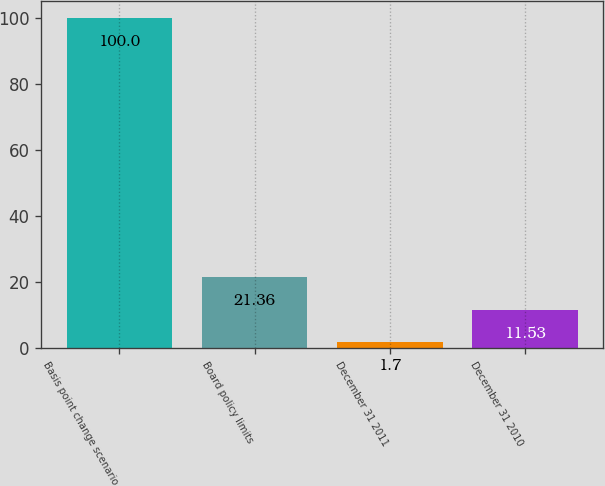Convert chart to OTSL. <chart><loc_0><loc_0><loc_500><loc_500><bar_chart><fcel>Basis point change scenario<fcel>Board policy limits<fcel>December 31 2011<fcel>December 31 2010<nl><fcel>100<fcel>21.36<fcel>1.7<fcel>11.53<nl></chart> 